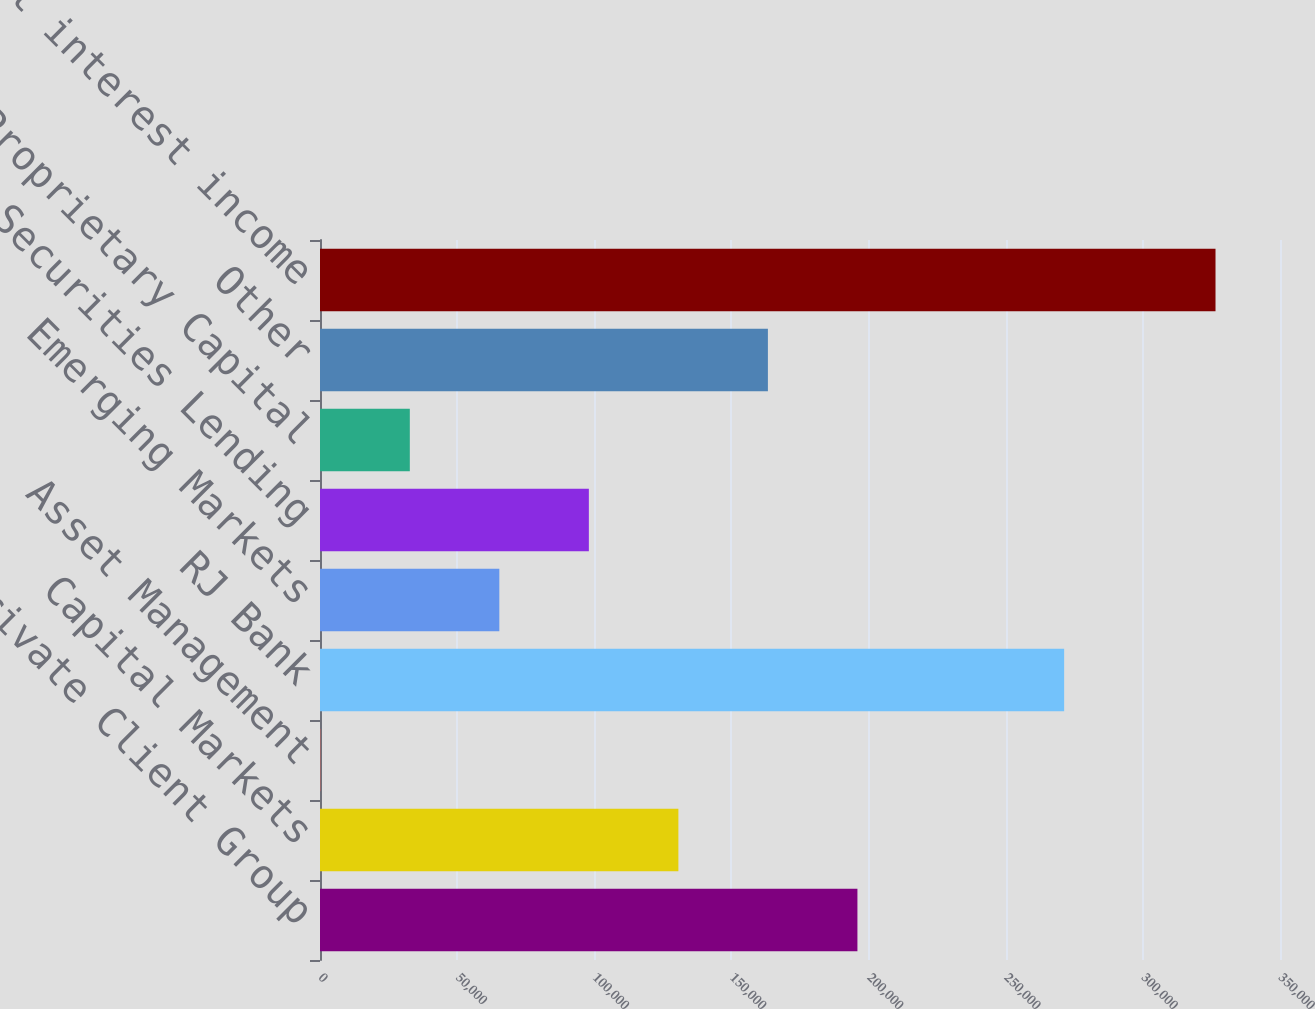Convert chart to OTSL. <chart><loc_0><loc_0><loc_500><loc_500><bar_chart><fcel>Private Client Group<fcel>Capital Markets<fcel>Asset Management<fcel>RJ Bank<fcel>Emerging Markets<fcel>Securities Lending<fcel>Proprietary Capital<fcel>Other<fcel>Net interest income<nl><fcel>195936<fcel>130659<fcel>107<fcel>271306<fcel>65383.2<fcel>98021.3<fcel>32745.1<fcel>163298<fcel>326488<nl></chart> 